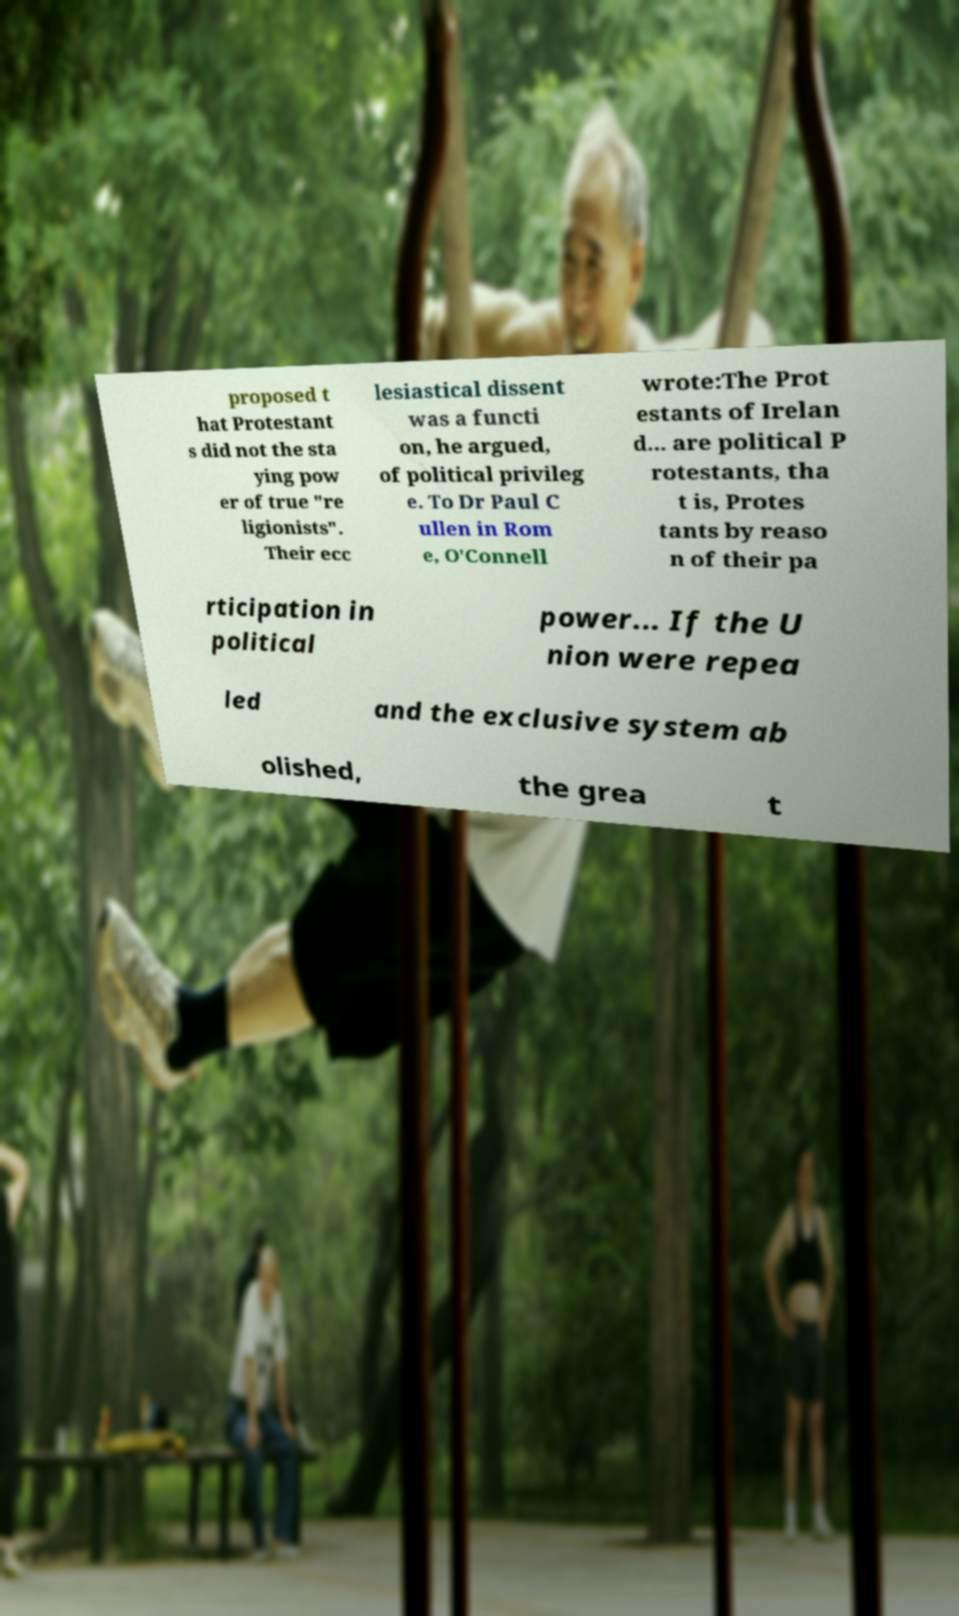Could you extract and type out the text from this image? proposed t hat Protestant s did not the sta ying pow er of true "re ligionists". Their ecc lesiastical dissent was a functi on, he argued, of political privileg e. To Dr Paul C ullen in Rom e, O'Connell wrote:The Prot estants of Irelan d... are political P rotestants, tha t is, Protes tants by reaso n of their pa rticipation in political power... If the U nion were repea led and the exclusive system ab olished, the grea t 